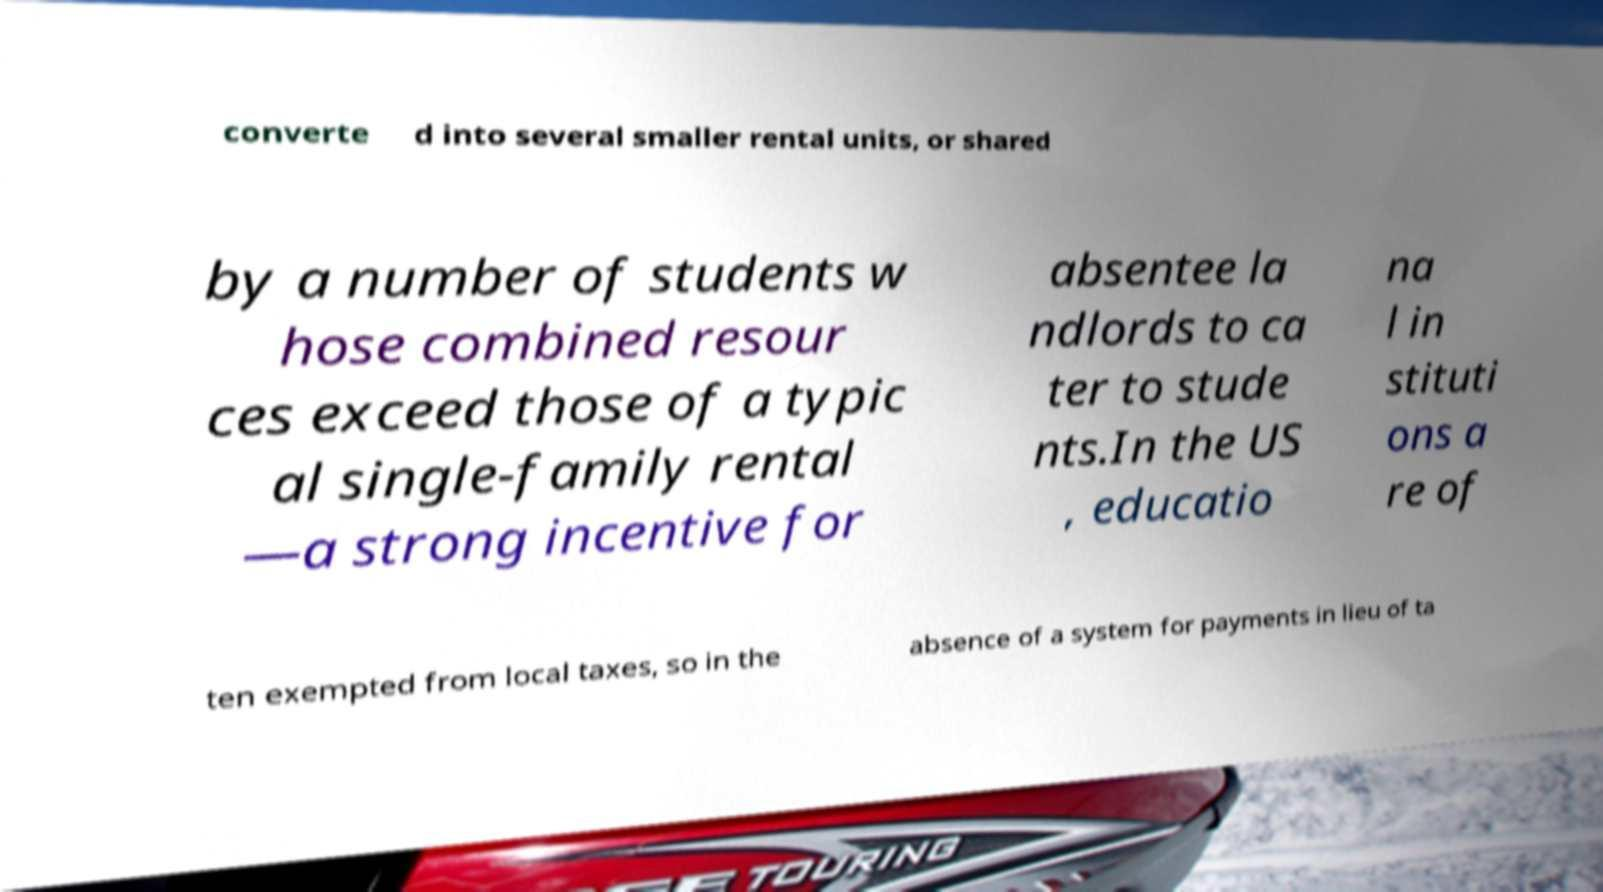Can you read and provide the text displayed in the image?This photo seems to have some interesting text. Can you extract and type it out for me? converte d into several smaller rental units, or shared by a number of students w hose combined resour ces exceed those of a typic al single-family rental —a strong incentive for absentee la ndlords to ca ter to stude nts.In the US , educatio na l in stituti ons a re of ten exempted from local taxes, so in the absence of a system for payments in lieu of ta 